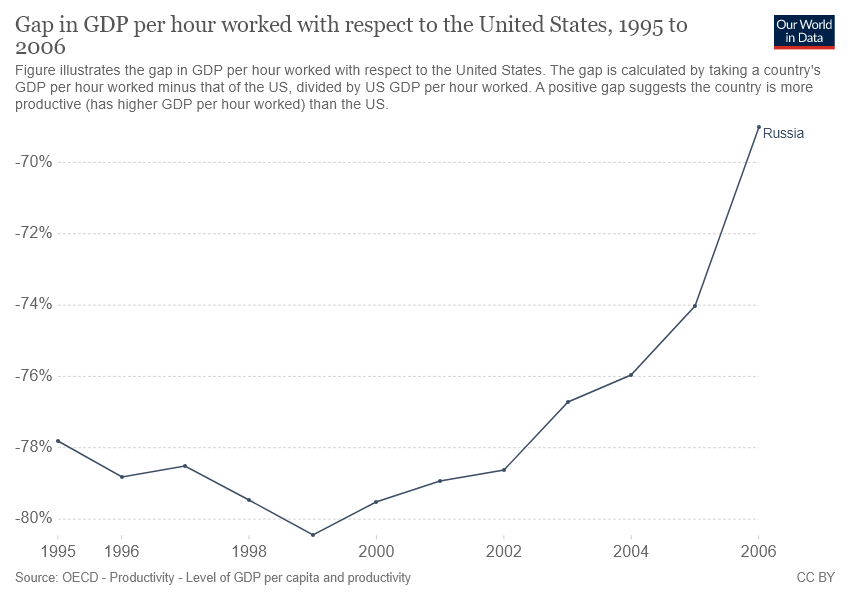Point out several critical features in this image. The data for the country is Russia. During the period from 2004 to 2006, there was a 68% increase in the number of percentage points. 